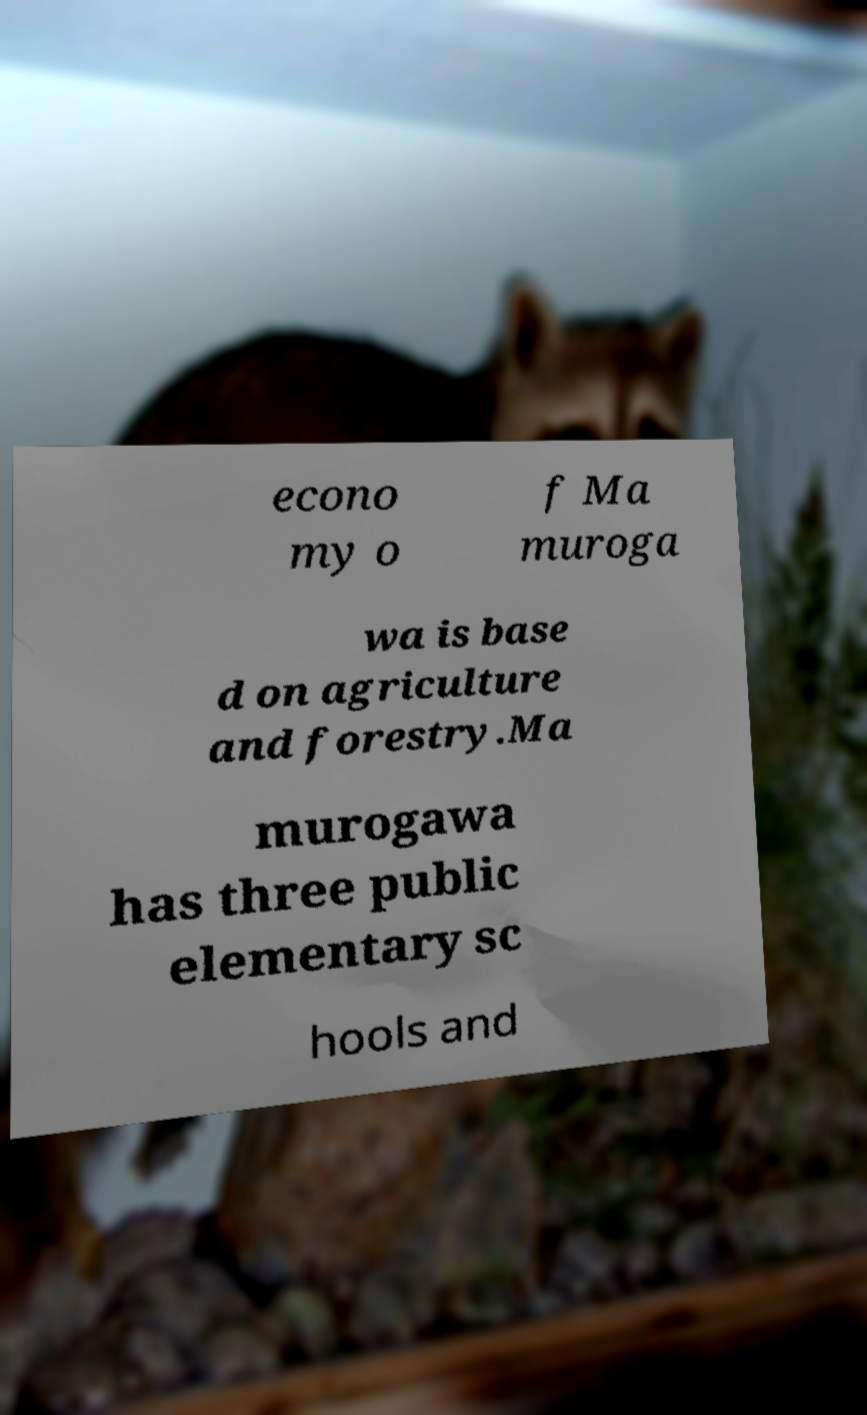What messages or text are displayed in this image? I need them in a readable, typed format. econo my o f Ma muroga wa is base d on agriculture and forestry.Ma murogawa has three public elementary sc hools and 